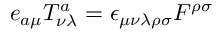<formula> <loc_0><loc_0><loc_500><loc_500>e _ { a \mu } T _ { \nu \lambda } ^ { a } = \epsilon _ { \mu \nu \lambda \rho \sigma } F ^ { \rho \sigma }</formula> 